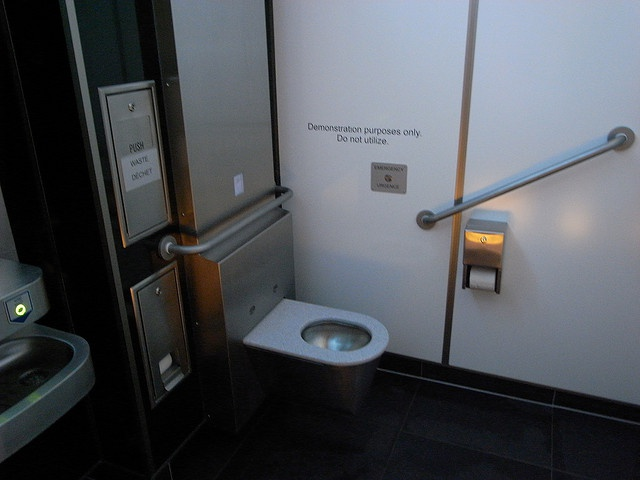Describe the objects in this image and their specific colors. I can see toilet in black and gray tones and sink in black, purple, gray, and darkblue tones in this image. 